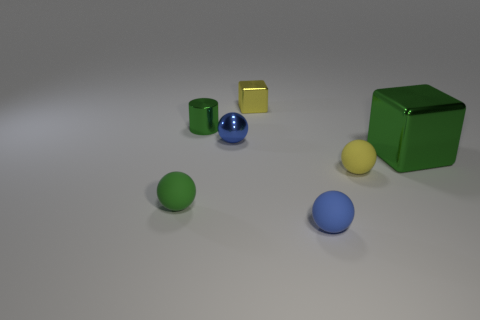Are there any patterns or alignments among the objects? Upon closer inspection, there doesn't seem to be a deliberate pattern or alignment. However, the objects are arranged in a manner that could suggest randomness or perhaps an artistic choice to spread them out unevenly, creating a balanced composition of shapes and colors within the space. 